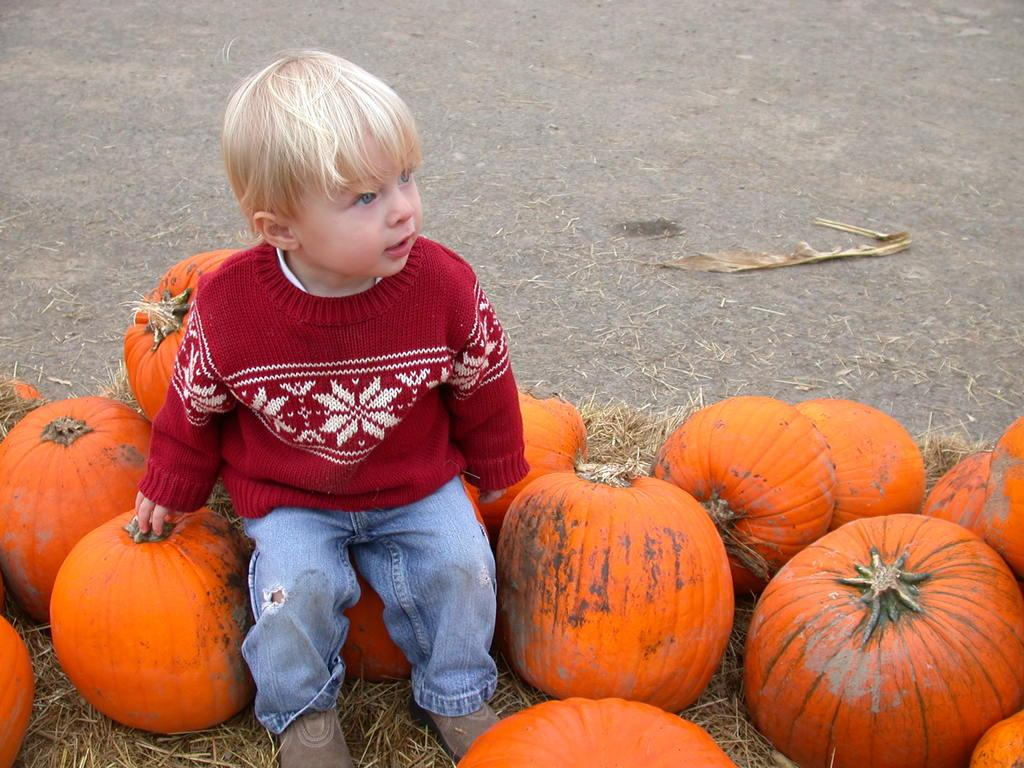What is the main subject of the image? The main subject of the image is a kid. Where is the kid located in the image? The kid is towards the left side of the image. What is the kid sitting on? The kid is sitting on pumpkins. What is the kid wearing? The kid is wearing a red sweater and blue jeans. What color are the pumpkins? The pumpkins are orange in color. Can you see any fangs on the kid in the image? There are no fangs visible on the kid in the image. What type of work is the kid doing while sitting on the pumpkins? The image does not show the kid doing any work; they are simply sitting on the pumpkins. 